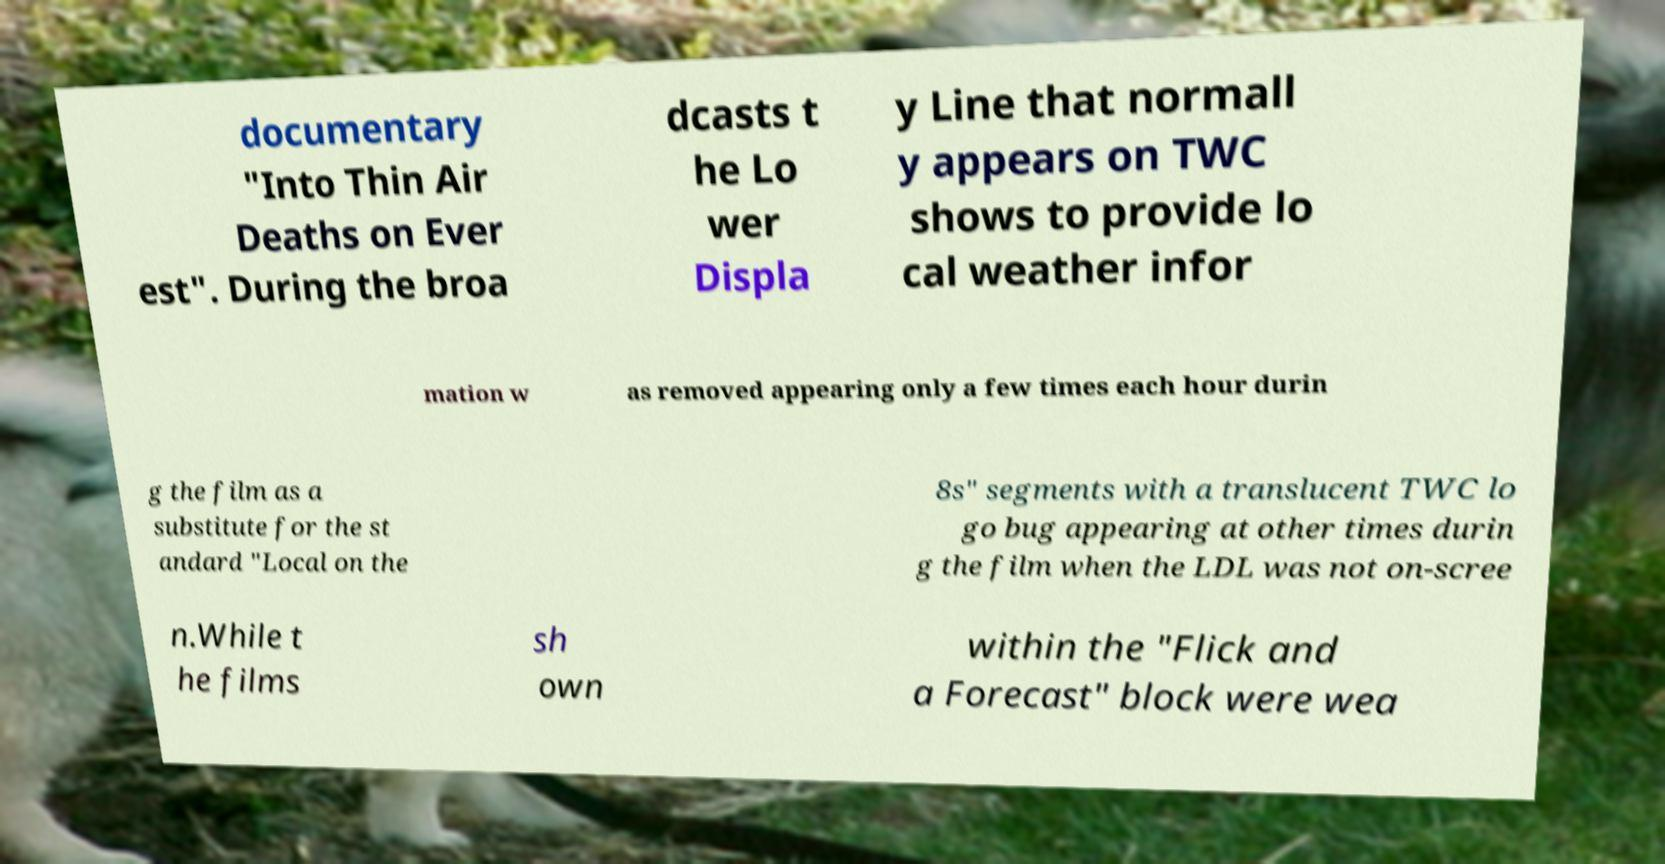Could you assist in decoding the text presented in this image and type it out clearly? documentary "Into Thin Air Deaths on Ever est". During the broa dcasts t he Lo wer Displa y Line that normall y appears on TWC shows to provide lo cal weather infor mation w as removed appearing only a few times each hour durin g the film as a substitute for the st andard "Local on the 8s" segments with a translucent TWC lo go bug appearing at other times durin g the film when the LDL was not on-scree n.While t he films sh own within the "Flick and a Forecast" block were wea 